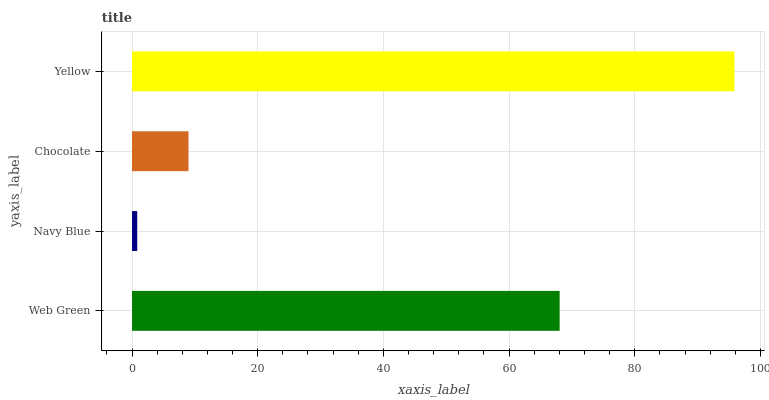Is Navy Blue the minimum?
Answer yes or no. Yes. Is Yellow the maximum?
Answer yes or no. Yes. Is Chocolate the minimum?
Answer yes or no. No. Is Chocolate the maximum?
Answer yes or no. No. Is Chocolate greater than Navy Blue?
Answer yes or no. Yes. Is Navy Blue less than Chocolate?
Answer yes or no. Yes. Is Navy Blue greater than Chocolate?
Answer yes or no. No. Is Chocolate less than Navy Blue?
Answer yes or no. No. Is Web Green the high median?
Answer yes or no. Yes. Is Chocolate the low median?
Answer yes or no. Yes. Is Navy Blue the high median?
Answer yes or no. No. Is Navy Blue the low median?
Answer yes or no. No. 